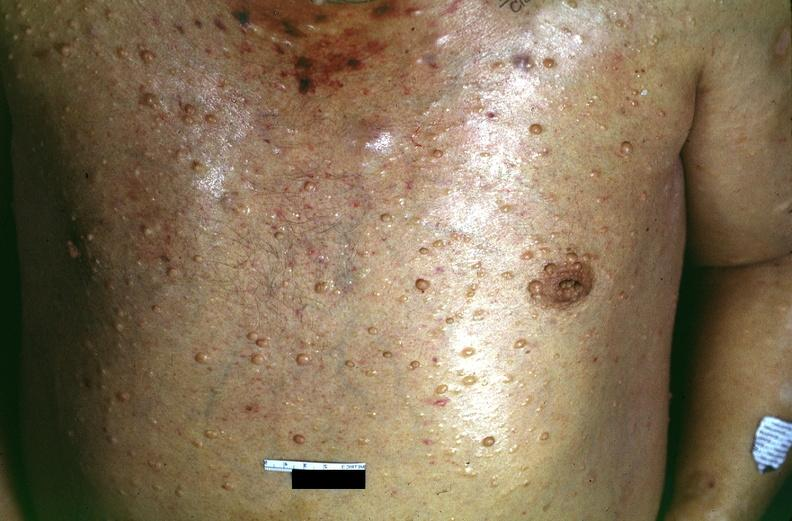does this image show skin, neurofibromatosis?
Answer the question using a single word or phrase. Yes 